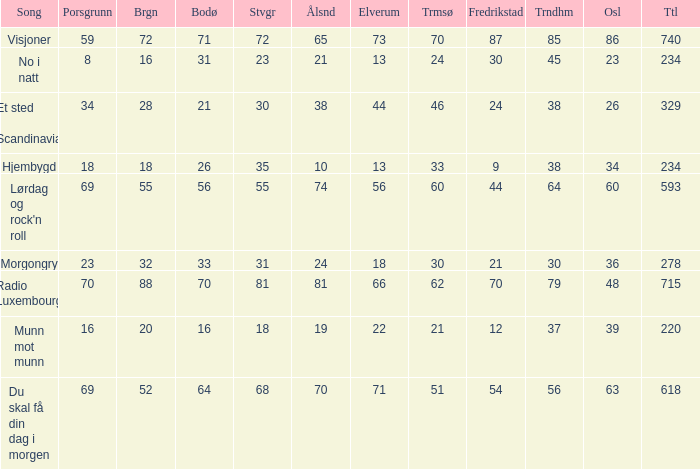What was the total for radio luxembourg? 715.0. 